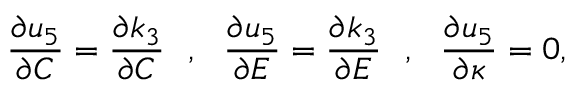<formula> <loc_0><loc_0><loc_500><loc_500>\frac { \partial u _ { 5 } } { \partial C } = \frac { \partial k _ { 3 } } { \partial C } , \frac { \partial u _ { 5 } } { \partial E } = \frac { \partial k _ { 3 } } { \partial E } , \frac { \partial u _ { 5 } } { \partial \kappa } = 0 ,</formula> 